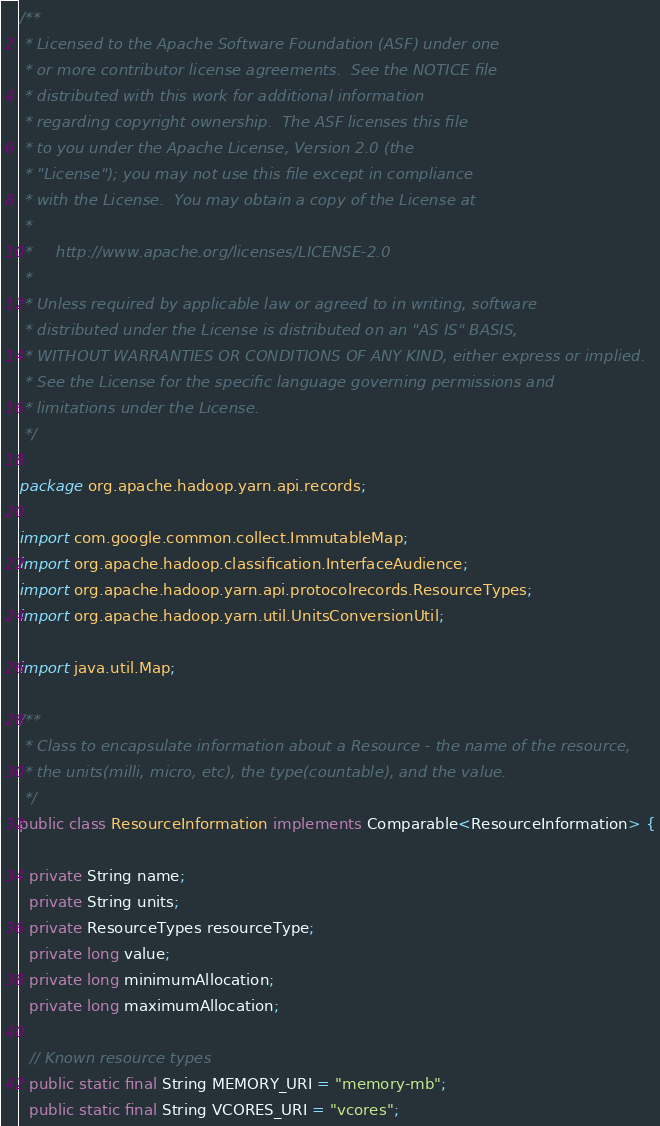Convert code to text. <code><loc_0><loc_0><loc_500><loc_500><_Java_>/**
 * Licensed to the Apache Software Foundation (ASF) under one
 * or more contributor license agreements.  See the NOTICE file
 * distributed with this work for additional information
 * regarding copyright ownership.  The ASF licenses this file
 * to you under the Apache License, Version 2.0 (the
 * "License"); you may not use this file except in compliance
 * with the License.  You may obtain a copy of the License at
 *
 *     http://www.apache.org/licenses/LICENSE-2.0
 *
 * Unless required by applicable law or agreed to in writing, software
 * distributed under the License is distributed on an "AS IS" BASIS,
 * WITHOUT WARRANTIES OR CONDITIONS OF ANY KIND, either express or implied.
 * See the License for the specific language governing permissions and
 * limitations under the License.
 */

package org.apache.hadoop.yarn.api.records;

import com.google.common.collect.ImmutableMap;
import org.apache.hadoop.classification.InterfaceAudience;
import org.apache.hadoop.yarn.api.protocolrecords.ResourceTypes;
import org.apache.hadoop.yarn.util.UnitsConversionUtil;

import java.util.Map;

/**
 * Class to encapsulate information about a Resource - the name of the resource,
 * the units(milli, micro, etc), the type(countable), and the value.
 */
public class ResourceInformation implements Comparable<ResourceInformation> {

  private String name;
  private String units;
  private ResourceTypes resourceType;
  private long value;
  private long minimumAllocation;
  private long maximumAllocation;

  // Known resource types
  public static final String MEMORY_URI = "memory-mb";
  public static final String VCORES_URI = "vcores";</code> 